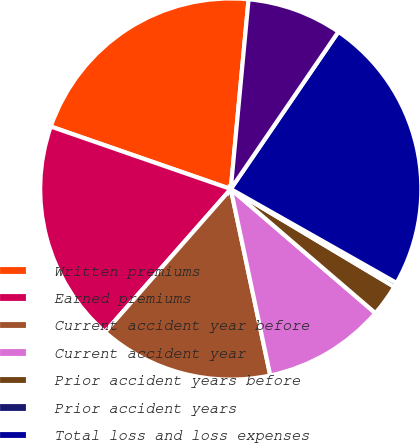Convert chart. <chart><loc_0><loc_0><loc_500><loc_500><pie_chart><fcel>Written premiums<fcel>Earned premiums<fcel>Current accident year before<fcel>Current accident year<fcel>Prior accident years before<fcel>Prior accident years<fcel>Total loss and loss expenses<fcel>Total loss and loss expense<nl><fcel>21.17%<fcel>18.84%<fcel>14.8%<fcel>10.39%<fcel>2.71%<fcel>0.38%<fcel>23.65%<fcel>8.06%<nl></chart> 